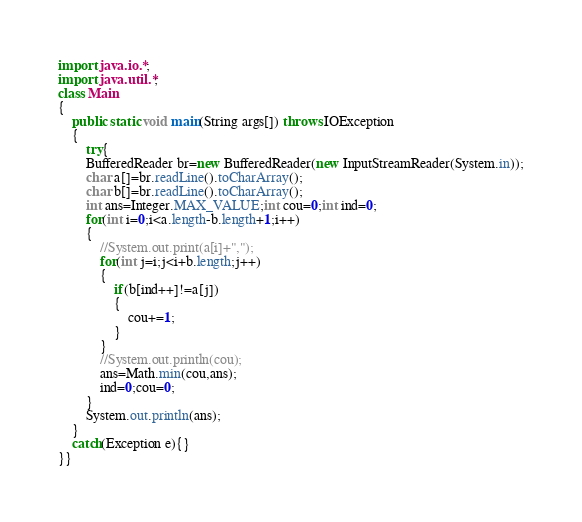Convert code to text. <code><loc_0><loc_0><loc_500><loc_500><_Java_>import java.io.*;
import java.util.*;
class Main
{
	public static void main(String args[]) throws IOException
	{
		try{
		BufferedReader br=new BufferedReader(new InputStreamReader(System.in));
		char a[]=br.readLine().toCharArray();
		char b[]=br.readLine().toCharArray();
		int ans=Integer.MAX_VALUE;int cou=0;int ind=0;
		for(int i=0;i<a.length-b.length+1;i++)
		{
			//System.out.print(a[i]+",");
			for(int j=i;j<i+b.length;j++)
			{
				if(b[ind++]!=a[j])
				{
					cou+=1;
				}
			}
			//System.out.println(cou);
			ans=Math.min(cou,ans);
			ind=0;cou=0;
		}
		System.out.println(ans);
	}
	catch(Exception e){}
}}</code> 